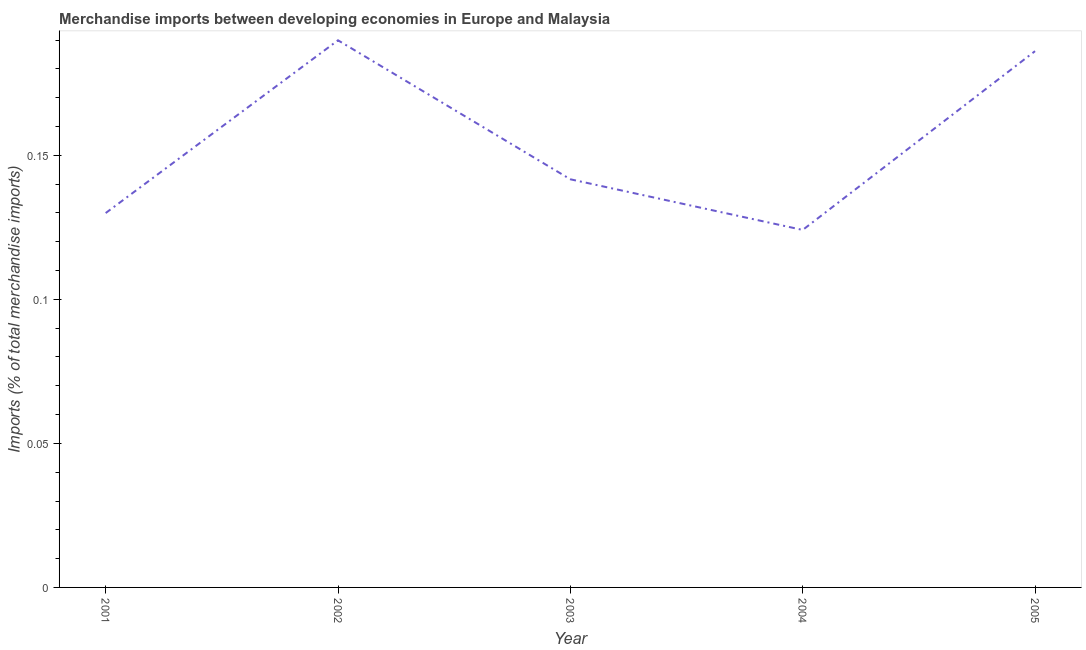What is the merchandise imports in 2004?
Provide a short and direct response. 0.12. Across all years, what is the maximum merchandise imports?
Your answer should be compact. 0.19. Across all years, what is the minimum merchandise imports?
Ensure brevity in your answer.  0.12. What is the sum of the merchandise imports?
Your response must be concise. 0.77. What is the difference between the merchandise imports in 2002 and 2005?
Your answer should be compact. 0. What is the average merchandise imports per year?
Give a very brief answer. 0.15. What is the median merchandise imports?
Offer a terse response. 0.14. In how many years, is the merchandise imports greater than 0.060000000000000005 %?
Give a very brief answer. 5. What is the ratio of the merchandise imports in 2003 to that in 2004?
Make the answer very short. 1.14. Is the merchandise imports in 2001 less than that in 2005?
Ensure brevity in your answer.  Yes. Is the difference between the merchandise imports in 2002 and 2005 greater than the difference between any two years?
Make the answer very short. No. What is the difference between the highest and the second highest merchandise imports?
Provide a short and direct response. 0. Is the sum of the merchandise imports in 2002 and 2004 greater than the maximum merchandise imports across all years?
Give a very brief answer. Yes. What is the difference between the highest and the lowest merchandise imports?
Provide a succinct answer. 0.07. In how many years, is the merchandise imports greater than the average merchandise imports taken over all years?
Ensure brevity in your answer.  2. Does the merchandise imports monotonically increase over the years?
Your response must be concise. No. Are the values on the major ticks of Y-axis written in scientific E-notation?
Offer a very short reply. No. What is the title of the graph?
Give a very brief answer. Merchandise imports between developing economies in Europe and Malaysia. What is the label or title of the Y-axis?
Keep it short and to the point. Imports (% of total merchandise imports). What is the Imports (% of total merchandise imports) in 2001?
Give a very brief answer. 0.13. What is the Imports (% of total merchandise imports) in 2002?
Give a very brief answer. 0.19. What is the Imports (% of total merchandise imports) in 2003?
Your answer should be compact. 0.14. What is the Imports (% of total merchandise imports) in 2004?
Make the answer very short. 0.12. What is the Imports (% of total merchandise imports) in 2005?
Offer a terse response. 0.19. What is the difference between the Imports (% of total merchandise imports) in 2001 and 2002?
Provide a succinct answer. -0.06. What is the difference between the Imports (% of total merchandise imports) in 2001 and 2003?
Keep it short and to the point. -0.01. What is the difference between the Imports (% of total merchandise imports) in 2001 and 2004?
Make the answer very short. 0.01. What is the difference between the Imports (% of total merchandise imports) in 2001 and 2005?
Keep it short and to the point. -0.06. What is the difference between the Imports (% of total merchandise imports) in 2002 and 2003?
Offer a very short reply. 0.05. What is the difference between the Imports (% of total merchandise imports) in 2002 and 2004?
Your response must be concise. 0.07. What is the difference between the Imports (% of total merchandise imports) in 2002 and 2005?
Ensure brevity in your answer.  0. What is the difference between the Imports (% of total merchandise imports) in 2003 and 2004?
Provide a short and direct response. 0.02. What is the difference between the Imports (% of total merchandise imports) in 2003 and 2005?
Your response must be concise. -0.04. What is the difference between the Imports (% of total merchandise imports) in 2004 and 2005?
Ensure brevity in your answer.  -0.06. What is the ratio of the Imports (% of total merchandise imports) in 2001 to that in 2002?
Offer a terse response. 0.68. What is the ratio of the Imports (% of total merchandise imports) in 2001 to that in 2003?
Your response must be concise. 0.92. What is the ratio of the Imports (% of total merchandise imports) in 2001 to that in 2004?
Provide a succinct answer. 1.05. What is the ratio of the Imports (% of total merchandise imports) in 2001 to that in 2005?
Offer a very short reply. 0.7. What is the ratio of the Imports (% of total merchandise imports) in 2002 to that in 2003?
Your answer should be very brief. 1.34. What is the ratio of the Imports (% of total merchandise imports) in 2002 to that in 2004?
Keep it short and to the point. 1.53. What is the ratio of the Imports (% of total merchandise imports) in 2003 to that in 2004?
Keep it short and to the point. 1.14. What is the ratio of the Imports (% of total merchandise imports) in 2003 to that in 2005?
Make the answer very short. 0.76. What is the ratio of the Imports (% of total merchandise imports) in 2004 to that in 2005?
Provide a short and direct response. 0.67. 